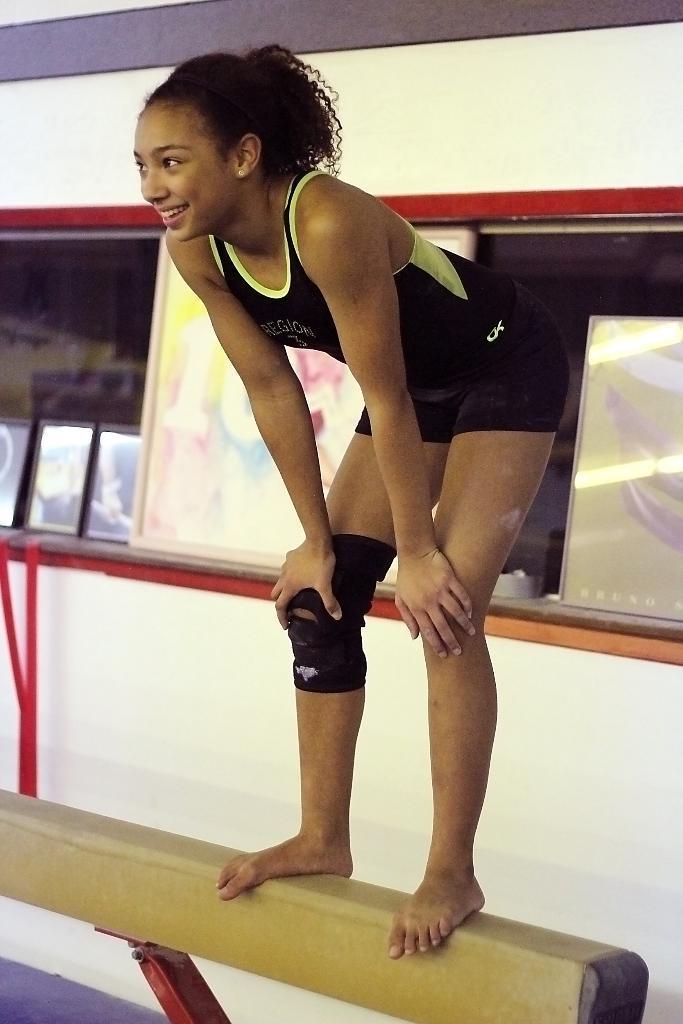In one or two sentences, can you explain what this image depicts? In this image we can see a woman standing on a pole. In the background we can see a mirror and photo frame. 